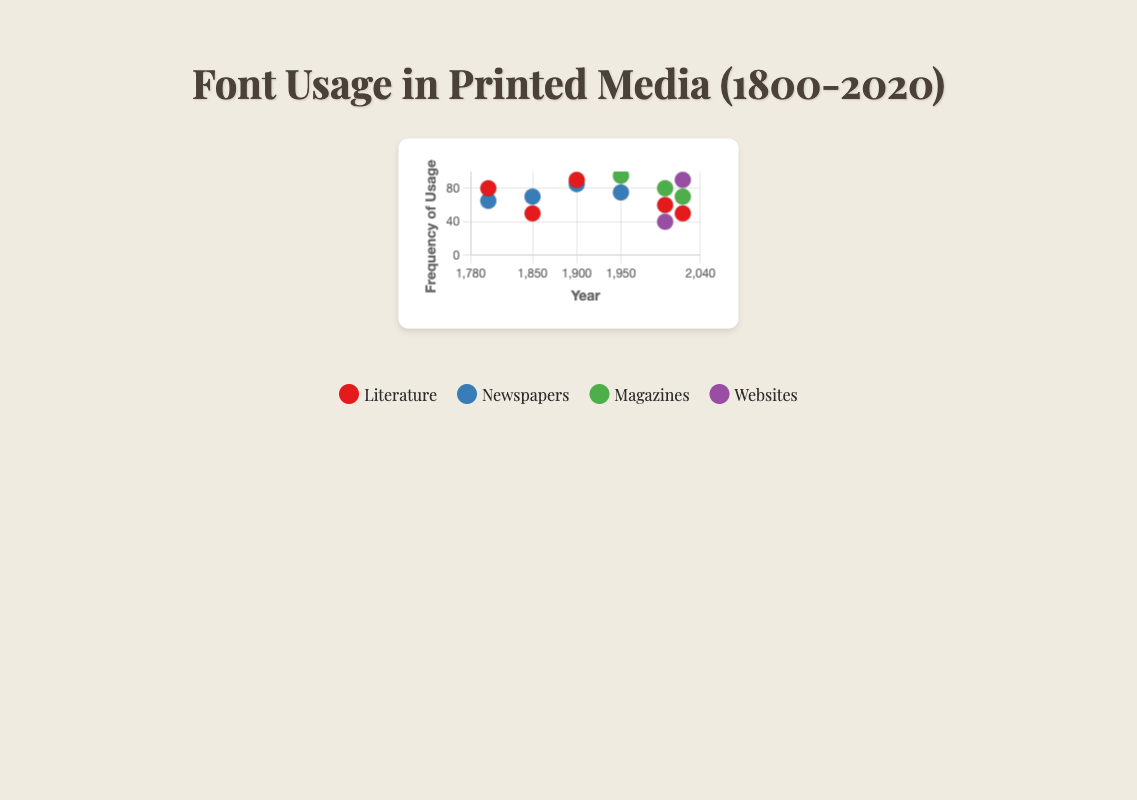What is the title of the scatter plot? The title is typically located at the top center of the plot. In this case, it is displayed prominently and indicates what the data in the scatter plot represents.
Answer: Font Usage in Printed Media (1800-2020) Which genre’s data point has the highest frequency in the year 1950? To determine this, locate the year 1950 on the x-axis and identify the data point with the highest y-value (frequency). The highest frequency data point in 1950 is for "Magazines" with the "Helvetica" typeface.
Answer: Magazines How many different typefaces are shown in the figure? To find this, count the unique typeface labels provided in the tooltip or legend for all data points. The typefaces are Caslon, Baskerville, Bodoni, Clarendon, Garamond, Times New Roman, Helvetica, Arial, Georgia, Verdana, Roboto, Proxima Nova.
Answer: 12 Which typeface saw the highest frequency in newspaper usage in the year 1900? Look for the "Newspapers" points for the year 1900 and compare the frequencies. The highest frequency in newspapers in 1900 is for "Times New Roman."
Answer: Times New Roman What is the average frequency of the typefaces used in the genre of "Literature" across all years? Identify and sum the frequencies for "Literature" in the years 1800, 1850, 1900, 2000, and 2020 (i.e., 80, 50, 90, 60, and 50). Then, divide this sum by the number of data points (5). (80 + 50 + 90 + 60 + 50) / 5 = 66
Answer: 66 Which genre has the most data points represented in the scatter plot? Count the number of data points (dots) for each genre in the plot. The genres are Literature, Newspapers, Magazines, and Websites. Newspapers have the most data points (5).
Answer: Newspapers Which year exhibits the highest overall frequency of typeface usage? To determine this, identify the heights of all the data points across each scatter point for different years and compare the highest frequencies. The year 1950 has the highest frequency data point of 95 for Helvetica in Magazines.
Answer: 1950 Between the years 1900 and 2020, which genre has shown a noticeable increase in typeface frequency? Compare the data points for all genres between 1900 and 2020. The "Websites" genre shows a noticeable increase, from not being represented in 1900 to having a frequency of 90 in 2020 with "Roboto."
Answer: Websites 